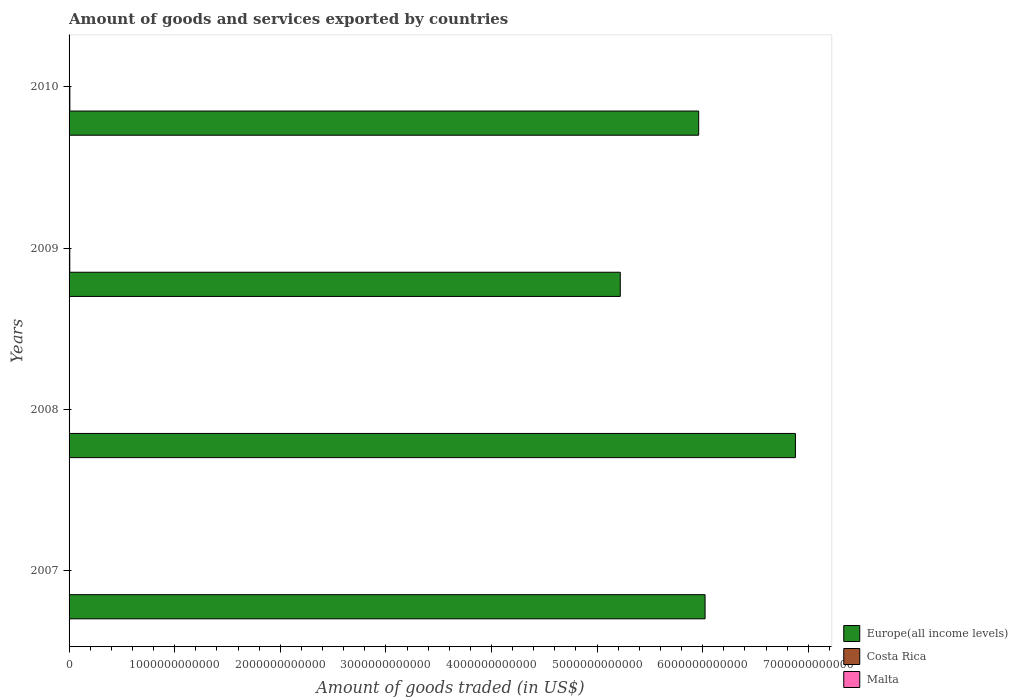Are the number of bars per tick equal to the number of legend labels?
Provide a succinct answer. Yes. How many bars are there on the 2nd tick from the bottom?
Ensure brevity in your answer.  3. In how many cases, is the number of bars for a given year not equal to the number of legend labels?
Your answer should be compact. 0. What is the total amount of goods and services exported in Costa Rica in 2007?
Provide a succinct answer. 3.86e+09. Across all years, what is the maximum total amount of goods and services exported in Malta?
Ensure brevity in your answer.  3.66e+09. Across all years, what is the minimum total amount of goods and services exported in Costa Rica?
Offer a very short reply. 3.86e+09. In which year was the total amount of goods and services exported in Malta minimum?
Make the answer very short. 2009. What is the total total amount of goods and services exported in Malta in the graph?
Provide a short and direct response. 1.35e+1. What is the difference between the total amount of goods and services exported in Europe(all income levels) in 2008 and that in 2010?
Offer a terse response. 9.16e+11. What is the difference between the total amount of goods and services exported in Costa Rica in 2009 and the total amount of goods and services exported in Europe(all income levels) in 2008?
Your answer should be very brief. -6.87e+12. What is the average total amount of goods and services exported in Costa Rica per year?
Make the answer very short. 5.61e+09. In the year 2009, what is the difference between the total amount of goods and services exported in Malta and total amount of goods and services exported in Europe(all income levels)?
Provide a short and direct response. -5.22e+12. In how many years, is the total amount of goods and services exported in Costa Rica greater than 4800000000000 US$?
Your answer should be compact. 0. What is the ratio of the total amount of goods and services exported in Costa Rica in 2009 to that in 2010?
Give a very brief answer. 0.89. Is the total amount of goods and services exported in Costa Rica in 2008 less than that in 2009?
Offer a terse response. Yes. What is the difference between the highest and the second highest total amount of goods and services exported in Malta?
Your answer should be very brief. 4.45e+06. What is the difference between the highest and the lowest total amount of goods and services exported in Malta?
Keep it short and to the point. 8.63e+08. What does the 1st bar from the top in 2008 represents?
Your answer should be very brief. Malta. What does the 1st bar from the bottom in 2009 represents?
Your answer should be very brief. Europe(all income levels). How many bars are there?
Offer a terse response. 12. What is the difference between two consecutive major ticks on the X-axis?
Your response must be concise. 1.00e+12. Does the graph contain any zero values?
Offer a very short reply. No. How many legend labels are there?
Provide a succinct answer. 3. How are the legend labels stacked?
Provide a short and direct response. Vertical. What is the title of the graph?
Your answer should be very brief. Amount of goods and services exported by countries. What is the label or title of the X-axis?
Give a very brief answer. Amount of goods traded (in US$). What is the Amount of goods traded (in US$) in Europe(all income levels) in 2007?
Keep it short and to the point. 6.02e+12. What is the Amount of goods traded (in US$) of Costa Rica in 2007?
Your answer should be very brief. 3.86e+09. What is the Amount of goods traded (in US$) of Malta in 2007?
Offer a very short reply. 3.66e+09. What is the Amount of goods traded (in US$) in Europe(all income levels) in 2008?
Offer a very short reply. 6.88e+12. What is the Amount of goods traded (in US$) of Costa Rica in 2008?
Offer a terse response. 4.37e+09. What is the Amount of goods traded (in US$) of Malta in 2008?
Provide a succinct answer. 3.65e+09. What is the Amount of goods traded (in US$) of Europe(all income levels) in 2009?
Your response must be concise. 5.22e+12. What is the Amount of goods traded (in US$) of Costa Rica in 2009?
Ensure brevity in your answer.  6.67e+09. What is the Amount of goods traded (in US$) in Malta in 2009?
Provide a short and direct response. 2.79e+09. What is the Amount of goods traded (in US$) in Europe(all income levels) in 2010?
Your response must be concise. 5.96e+12. What is the Amount of goods traded (in US$) of Costa Rica in 2010?
Keep it short and to the point. 7.53e+09. What is the Amount of goods traded (in US$) in Malta in 2010?
Your answer should be very brief. 3.35e+09. Across all years, what is the maximum Amount of goods traded (in US$) of Europe(all income levels)?
Your response must be concise. 6.88e+12. Across all years, what is the maximum Amount of goods traded (in US$) of Costa Rica?
Ensure brevity in your answer.  7.53e+09. Across all years, what is the maximum Amount of goods traded (in US$) in Malta?
Your response must be concise. 3.66e+09. Across all years, what is the minimum Amount of goods traded (in US$) in Europe(all income levels)?
Offer a terse response. 5.22e+12. Across all years, what is the minimum Amount of goods traded (in US$) in Costa Rica?
Provide a succinct answer. 3.86e+09. Across all years, what is the minimum Amount of goods traded (in US$) of Malta?
Offer a terse response. 2.79e+09. What is the total Amount of goods traded (in US$) in Europe(all income levels) in the graph?
Keep it short and to the point. 2.41e+13. What is the total Amount of goods traded (in US$) of Costa Rica in the graph?
Give a very brief answer. 2.24e+1. What is the total Amount of goods traded (in US$) in Malta in the graph?
Make the answer very short. 1.35e+1. What is the difference between the Amount of goods traded (in US$) in Europe(all income levels) in 2007 and that in 2008?
Provide a succinct answer. -8.55e+11. What is the difference between the Amount of goods traded (in US$) in Costa Rica in 2007 and that in 2008?
Make the answer very short. -5.10e+08. What is the difference between the Amount of goods traded (in US$) in Malta in 2007 and that in 2008?
Provide a short and direct response. 4.45e+06. What is the difference between the Amount of goods traded (in US$) of Europe(all income levels) in 2007 and that in 2009?
Offer a very short reply. 8.03e+11. What is the difference between the Amount of goods traded (in US$) of Costa Rica in 2007 and that in 2009?
Make the answer very short. -2.81e+09. What is the difference between the Amount of goods traded (in US$) of Malta in 2007 and that in 2009?
Provide a succinct answer. 8.63e+08. What is the difference between the Amount of goods traded (in US$) of Europe(all income levels) in 2007 and that in 2010?
Ensure brevity in your answer.  6.07e+1. What is the difference between the Amount of goods traded (in US$) in Costa Rica in 2007 and that in 2010?
Make the answer very short. -3.67e+09. What is the difference between the Amount of goods traded (in US$) of Malta in 2007 and that in 2010?
Your response must be concise. 3.11e+08. What is the difference between the Amount of goods traded (in US$) of Europe(all income levels) in 2008 and that in 2009?
Make the answer very short. 1.66e+12. What is the difference between the Amount of goods traded (in US$) in Costa Rica in 2008 and that in 2009?
Your answer should be very brief. -2.30e+09. What is the difference between the Amount of goods traded (in US$) in Malta in 2008 and that in 2009?
Your answer should be compact. 8.58e+08. What is the difference between the Amount of goods traded (in US$) in Europe(all income levels) in 2008 and that in 2010?
Give a very brief answer. 9.16e+11. What is the difference between the Amount of goods traded (in US$) of Costa Rica in 2008 and that in 2010?
Offer a terse response. -3.16e+09. What is the difference between the Amount of goods traded (in US$) in Malta in 2008 and that in 2010?
Keep it short and to the point. 3.06e+08. What is the difference between the Amount of goods traded (in US$) of Europe(all income levels) in 2009 and that in 2010?
Offer a terse response. -7.42e+11. What is the difference between the Amount of goods traded (in US$) in Costa Rica in 2009 and that in 2010?
Your answer should be compact. -8.59e+08. What is the difference between the Amount of goods traded (in US$) in Malta in 2009 and that in 2010?
Your answer should be very brief. -5.52e+08. What is the difference between the Amount of goods traded (in US$) of Europe(all income levels) in 2007 and the Amount of goods traded (in US$) of Costa Rica in 2008?
Give a very brief answer. 6.02e+12. What is the difference between the Amount of goods traded (in US$) of Europe(all income levels) in 2007 and the Amount of goods traded (in US$) of Malta in 2008?
Give a very brief answer. 6.02e+12. What is the difference between the Amount of goods traded (in US$) of Costa Rica in 2007 and the Amount of goods traded (in US$) of Malta in 2008?
Your response must be concise. 2.07e+08. What is the difference between the Amount of goods traded (in US$) of Europe(all income levels) in 2007 and the Amount of goods traded (in US$) of Costa Rica in 2009?
Your answer should be very brief. 6.02e+12. What is the difference between the Amount of goods traded (in US$) of Europe(all income levels) in 2007 and the Amount of goods traded (in US$) of Malta in 2009?
Your response must be concise. 6.02e+12. What is the difference between the Amount of goods traded (in US$) of Costa Rica in 2007 and the Amount of goods traded (in US$) of Malta in 2009?
Your answer should be very brief. 1.07e+09. What is the difference between the Amount of goods traded (in US$) in Europe(all income levels) in 2007 and the Amount of goods traded (in US$) in Costa Rica in 2010?
Give a very brief answer. 6.01e+12. What is the difference between the Amount of goods traded (in US$) in Europe(all income levels) in 2007 and the Amount of goods traded (in US$) in Malta in 2010?
Your answer should be very brief. 6.02e+12. What is the difference between the Amount of goods traded (in US$) of Costa Rica in 2007 and the Amount of goods traded (in US$) of Malta in 2010?
Your response must be concise. 5.14e+08. What is the difference between the Amount of goods traded (in US$) of Europe(all income levels) in 2008 and the Amount of goods traded (in US$) of Costa Rica in 2009?
Your answer should be very brief. 6.87e+12. What is the difference between the Amount of goods traded (in US$) in Europe(all income levels) in 2008 and the Amount of goods traded (in US$) in Malta in 2009?
Offer a terse response. 6.88e+12. What is the difference between the Amount of goods traded (in US$) in Costa Rica in 2008 and the Amount of goods traded (in US$) in Malta in 2009?
Give a very brief answer. 1.58e+09. What is the difference between the Amount of goods traded (in US$) of Europe(all income levels) in 2008 and the Amount of goods traded (in US$) of Costa Rica in 2010?
Your answer should be compact. 6.87e+12. What is the difference between the Amount of goods traded (in US$) of Europe(all income levels) in 2008 and the Amount of goods traded (in US$) of Malta in 2010?
Your response must be concise. 6.87e+12. What is the difference between the Amount of goods traded (in US$) in Costa Rica in 2008 and the Amount of goods traded (in US$) in Malta in 2010?
Your answer should be very brief. 1.02e+09. What is the difference between the Amount of goods traded (in US$) of Europe(all income levels) in 2009 and the Amount of goods traded (in US$) of Costa Rica in 2010?
Make the answer very short. 5.21e+12. What is the difference between the Amount of goods traded (in US$) in Europe(all income levels) in 2009 and the Amount of goods traded (in US$) in Malta in 2010?
Ensure brevity in your answer.  5.22e+12. What is the difference between the Amount of goods traded (in US$) of Costa Rica in 2009 and the Amount of goods traded (in US$) of Malta in 2010?
Offer a very short reply. 3.32e+09. What is the average Amount of goods traded (in US$) of Europe(all income levels) per year?
Your answer should be compact. 6.02e+12. What is the average Amount of goods traded (in US$) of Costa Rica per year?
Keep it short and to the point. 5.61e+09. What is the average Amount of goods traded (in US$) in Malta per year?
Give a very brief answer. 3.36e+09. In the year 2007, what is the difference between the Amount of goods traded (in US$) in Europe(all income levels) and Amount of goods traded (in US$) in Costa Rica?
Make the answer very short. 6.02e+12. In the year 2007, what is the difference between the Amount of goods traded (in US$) in Europe(all income levels) and Amount of goods traded (in US$) in Malta?
Offer a very short reply. 6.02e+12. In the year 2007, what is the difference between the Amount of goods traded (in US$) of Costa Rica and Amount of goods traded (in US$) of Malta?
Your answer should be compact. 2.03e+08. In the year 2008, what is the difference between the Amount of goods traded (in US$) in Europe(all income levels) and Amount of goods traded (in US$) in Costa Rica?
Ensure brevity in your answer.  6.87e+12. In the year 2008, what is the difference between the Amount of goods traded (in US$) in Europe(all income levels) and Amount of goods traded (in US$) in Malta?
Give a very brief answer. 6.87e+12. In the year 2008, what is the difference between the Amount of goods traded (in US$) in Costa Rica and Amount of goods traded (in US$) in Malta?
Offer a very short reply. 7.18e+08. In the year 2009, what is the difference between the Amount of goods traded (in US$) of Europe(all income levels) and Amount of goods traded (in US$) of Costa Rica?
Your response must be concise. 5.21e+12. In the year 2009, what is the difference between the Amount of goods traded (in US$) in Europe(all income levels) and Amount of goods traded (in US$) in Malta?
Your response must be concise. 5.22e+12. In the year 2009, what is the difference between the Amount of goods traded (in US$) in Costa Rica and Amount of goods traded (in US$) in Malta?
Offer a very short reply. 3.88e+09. In the year 2010, what is the difference between the Amount of goods traded (in US$) of Europe(all income levels) and Amount of goods traded (in US$) of Costa Rica?
Provide a succinct answer. 5.95e+12. In the year 2010, what is the difference between the Amount of goods traded (in US$) in Europe(all income levels) and Amount of goods traded (in US$) in Malta?
Your answer should be compact. 5.96e+12. In the year 2010, what is the difference between the Amount of goods traded (in US$) in Costa Rica and Amount of goods traded (in US$) in Malta?
Your answer should be compact. 4.18e+09. What is the ratio of the Amount of goods traded (in US$) in Europe(all income levels) in 2007 to that in 2008?
Your answer should be very brief. 0.88. What is the ratio of the Amount of goods traded (in US$) in Costa Rica in 2007 to that in 2008?
Provide a succinct answer. 0.88. What is the ratio of the Amount of goods traded (in US$) of Malta in 2007 to that in 2008?
Give a very brief answer. 1. What is the ratio of the Amount of goods traded (in US$) in Europe(all income levels) in 2007 to that in 2009?
Give a very brief answer. 1.15. What is the ratio of the Amount of goods traded (in US$) in Costa Rica in 2007 to that in 2009?
Make the answer very short. 0.58. What is the ratio of the Amount of goods traded (in US$) in Malta in 2007 to that in 2009?
Keep it short and to the point. 1.31. What is the ratio of the Amount of goods traded (in US$) of Europe(all income levels) in 2007 to that in 2010?
Offer a terse response. 1.01. What is the ratio of the Amount of goods traded (in US$) in Costa Rica in 2007 to that in 2010?
Your answer should be compact. 0.51. What is the ratio of the Amount of goods traded (in US$) of Malta in 2007 to that in 2010?
Make the answer very short. 1.09. What is the ratio of the Amount of goods traded (in US$) in Europe(all income levels) in 2008 to that in 2009?
Your answer should be very brief. 1.32. What is the ratio of the Amount of goods traded (in US$) of Costa Rica in 2008 to that in 2009?
Your answer should be very brief. 0.66. What is the ratio of the Amount of goods traded (in US$) in Malta in 2008 to that in 2009?
Provide a succinct answer. 1.31. What is the ratio of the Amount of goods traded (in US$) of Europe(all income levels) in 2008 to that in 2010?
Offer a very short reply. 1.15. What is the ratio of the Amount of goods traded (in US$) of Costa Rica in 2008 to that in 2010?
Make the answer very short. 0.58. What is the ratio of the Amount of goods traded (in US$) of Malta in 2008 to that in 2010?
Ensure brevity in your answer.  1.09. What is the ratio of the Amount of goods traded (in US$) of Europe(all income levels) in 2009 to that in 2010?
Provide a short and direct response. 0.88. What is the ratio of the Amount of goods traded (in US$) of Costa Rica in 2009 to that in 2010?
Your answer should be very brief. 0.89. What is the ratio of the Amount of goods traded (in US$) in Malta in 2009 to that in 2010?
Offer a very short reply. 0.84. What is the difference between the highest and the second highest Amount of goods traded (in US$) in Europe(all income levels)?
Your answer should be compact. 8.55e+11. What is the difference between the highest and the second highest Amount of goods traded (in US$) in Costa Rica?
Offer a terse response. 8.59e+08. What is the difference between the highest and the second highest Amount of goods traded (in US$) in Malta?
Offer a terse response. 4.45e+06. What is the difference between the highest and the lowest Amount of goods traded (in US$) in Europe(all income levels)?
Ensure brevity in your answer.  1.66e+12. What is the difference between the highest and the lowest Amount of goods traded (in US$) in Costa Rica?
Provide a short and direct response. 3.67e+09. What is the difference between the highest and the lowest Amount of goods traded (in US$) in Malta?
Provide a succinct answer. 8.63e+08. 